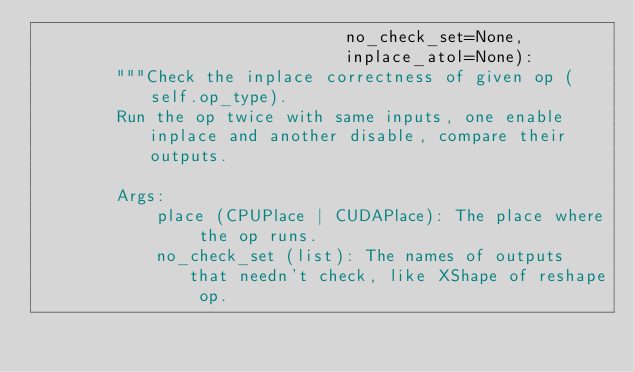Convert code to text. <code><loc_0><loc_0><loc_500><loc_500><_Python_>                               no_check_set=None,
                               inplace_atol=None):
        """Check the inplace correctness of given op (self.op_type).
        Run the op twice with same inputs, one enable inplace and another disable, compare their outputs.

        Args:
            place (CPUPlace | CUDAPlace): The place where the op runs.
            no_check_set (list): The names of outputs that needn't check, like XShape of reshape op.</code> 